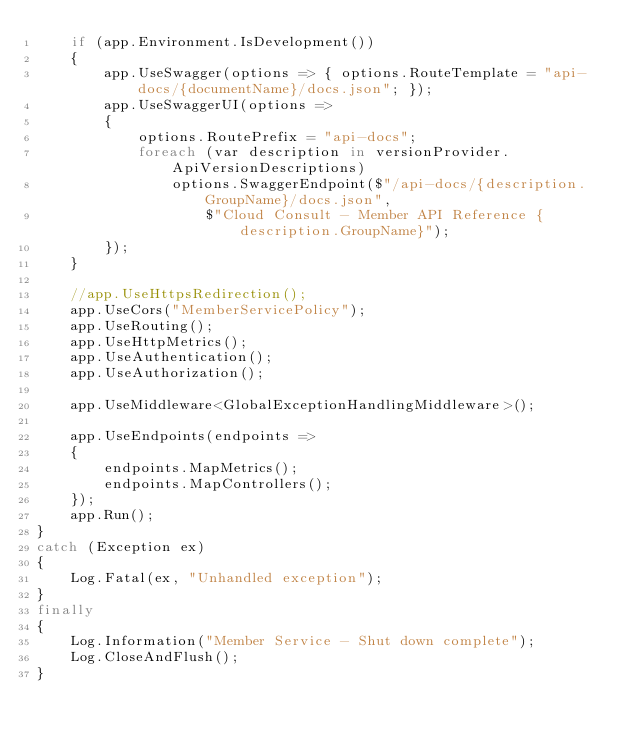Convert code to text. <code><loc_0><loc_0><loc_500><loc_500><_C#_>    if (app.Environment.IsDevelopment())
    {
        app.UseSwagger(options => { options.RouteTemplate = "api-docs/{documentName}/docs.json"; });
        app.UseSwaggerUI(options =>
        {
            options.RoutePrefix = "api-docs";
            foreach (var description in versionProvider.ApiVersionDescriptions)
                options.SwaggerEndpoint($"/api-docs/{description.GroupName}/docs.json",
                    $"Cloud Consult - Member API Reference {description.GroupName}");
        });
    }

    //app.UseHttpsRedirection();
    app.UseCors("MemberServicePolicy");
    app.UseRouting();
    app.UseHttpMetrics();
    app.UseAuthentication();
    app.UseAuthorization();

    app.UseMiddleware<GlobalExceptionHandlingMiddleware>();

    app.UseEndpoints(endpoints =>
    {
        endpoints.MapMetrics();
        endpoints.MapControllers();
    });
    app.Run();
}
catch (Exception ex)
{
    Log.Fatal(ex, "Unhandled exception");
}
finally
{
    Log.Information("Member Service - Shut down complete");
    Log.CloseAndFlush();
}</code> 